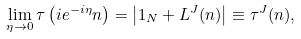<formula> <loc_0><loc_0><loc_500><loc_500>\lim _ { \eta \to 0 } \tau \left ( i e ^ { - i \eta } n \right ) = \left | { 1 } _ { N } + L ^ { J } ( n ) \right | \equiv \tau ^ { J } ( n ) ,</formula> 